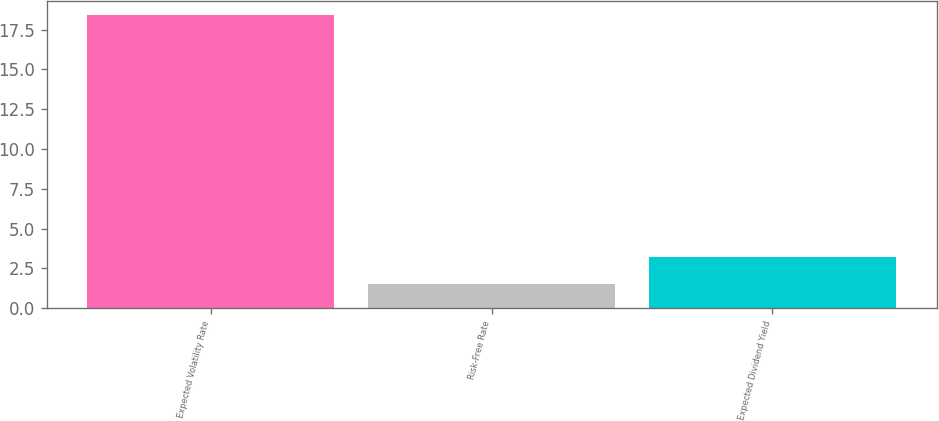Convert chart to OTSL. <chart><loc_0><loc_0><loc_500><loc_500><bar_chart><fcel>Expected Volatility Rate<fcel>Risk-Free Rate<fcel>Expected Dividend Yield<nl><fcel>18.4<fcel>1.5<fcel>3.19<nl></chart> 